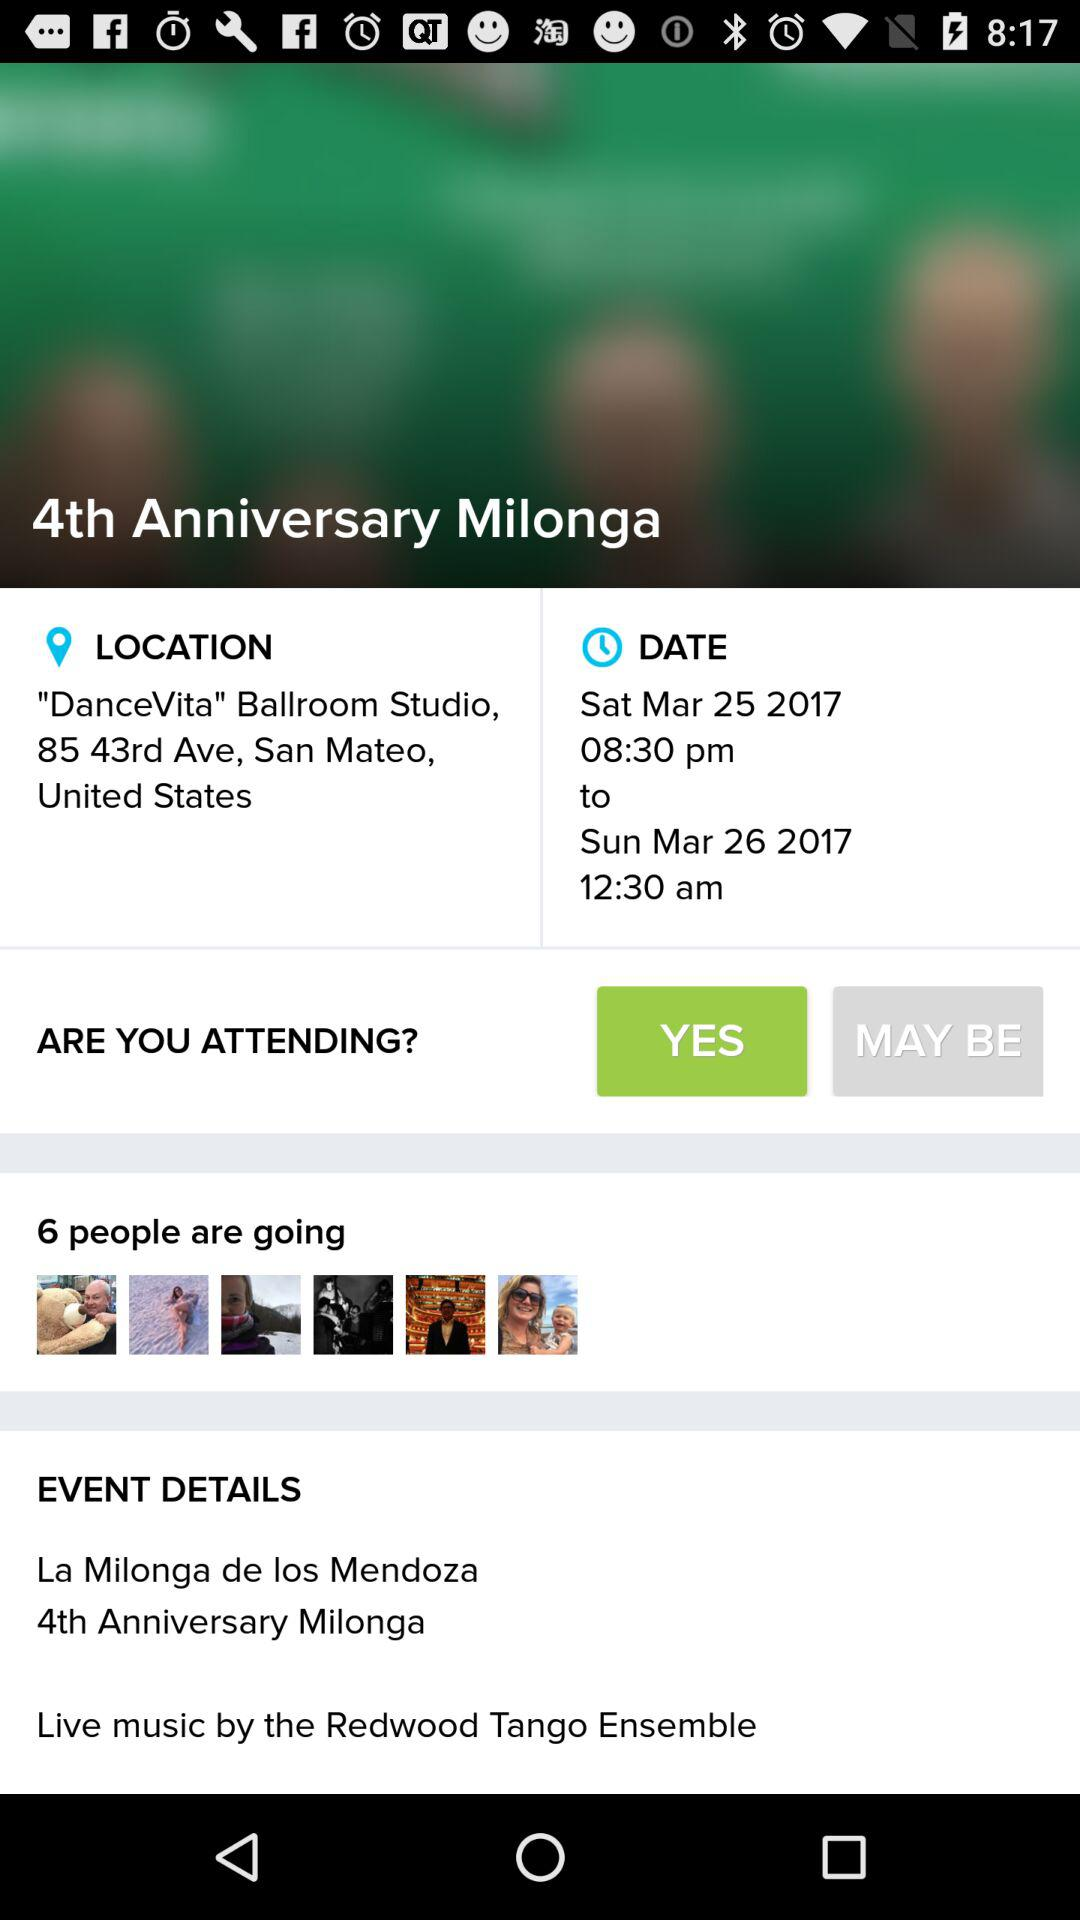What is the date? The date is Sunday, April 02, 2017. 